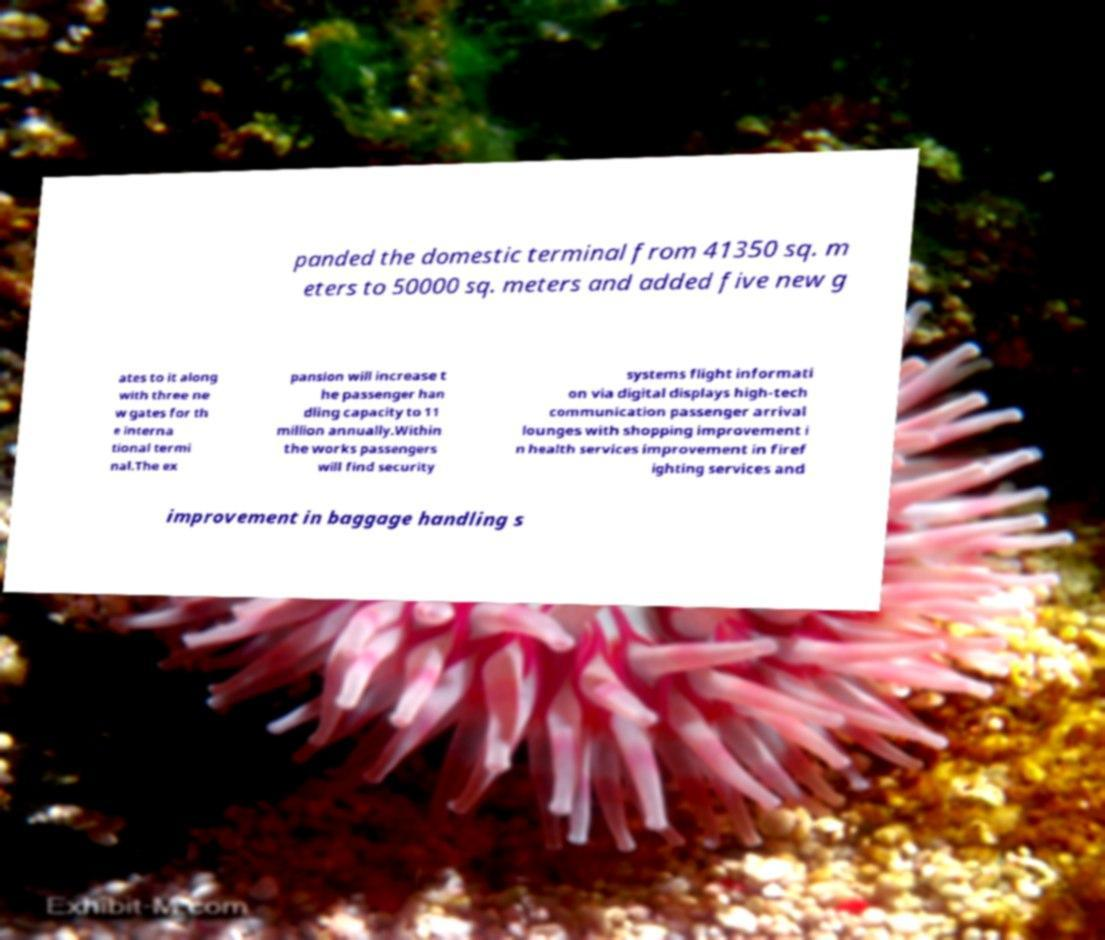There's text embedded in this image that I need extracted. Can you transcribe it verbatim? panded the domestic terminal from 41350 sq. m eters to 50000 sq. meters and added five new g ates to it along with three ne w gates for th e interna tional termi nal.The ex pansion will increase t he passenger han dling capacity to 11 million annually.Within the works passengers will find security systems flight informati on via digital displays high-tech communication passenger arrival lounges with shopping improvement i n health services improvement in firef ighting services and improvement in baggage handling s 